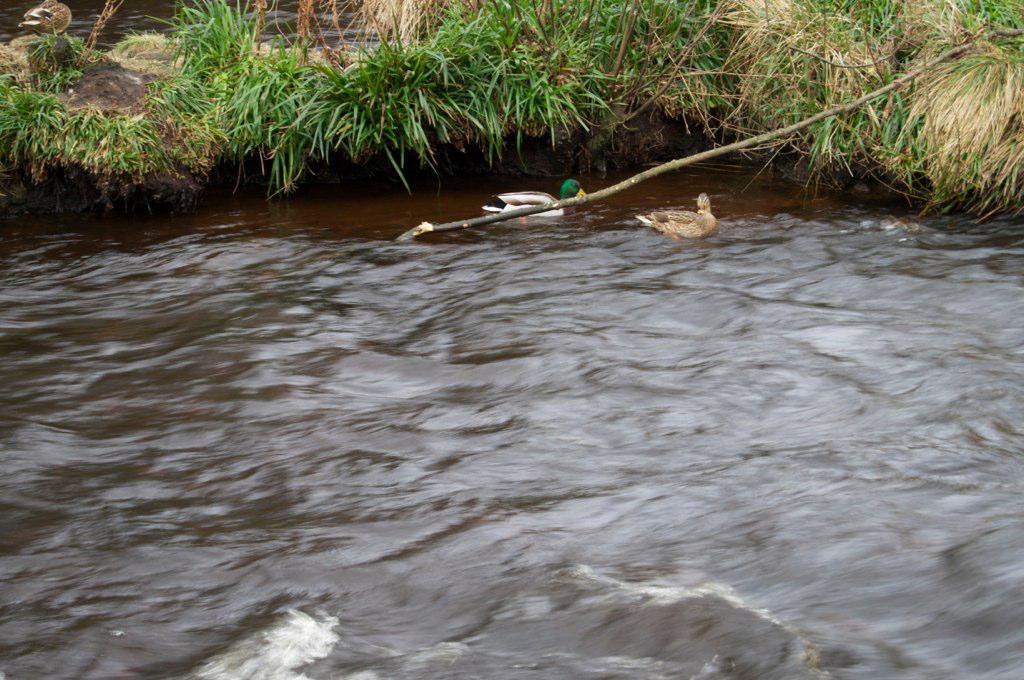How would you summarize this image in a sentence or two? In this picture we can see few ducks on the water, in the background we can find few plants. 